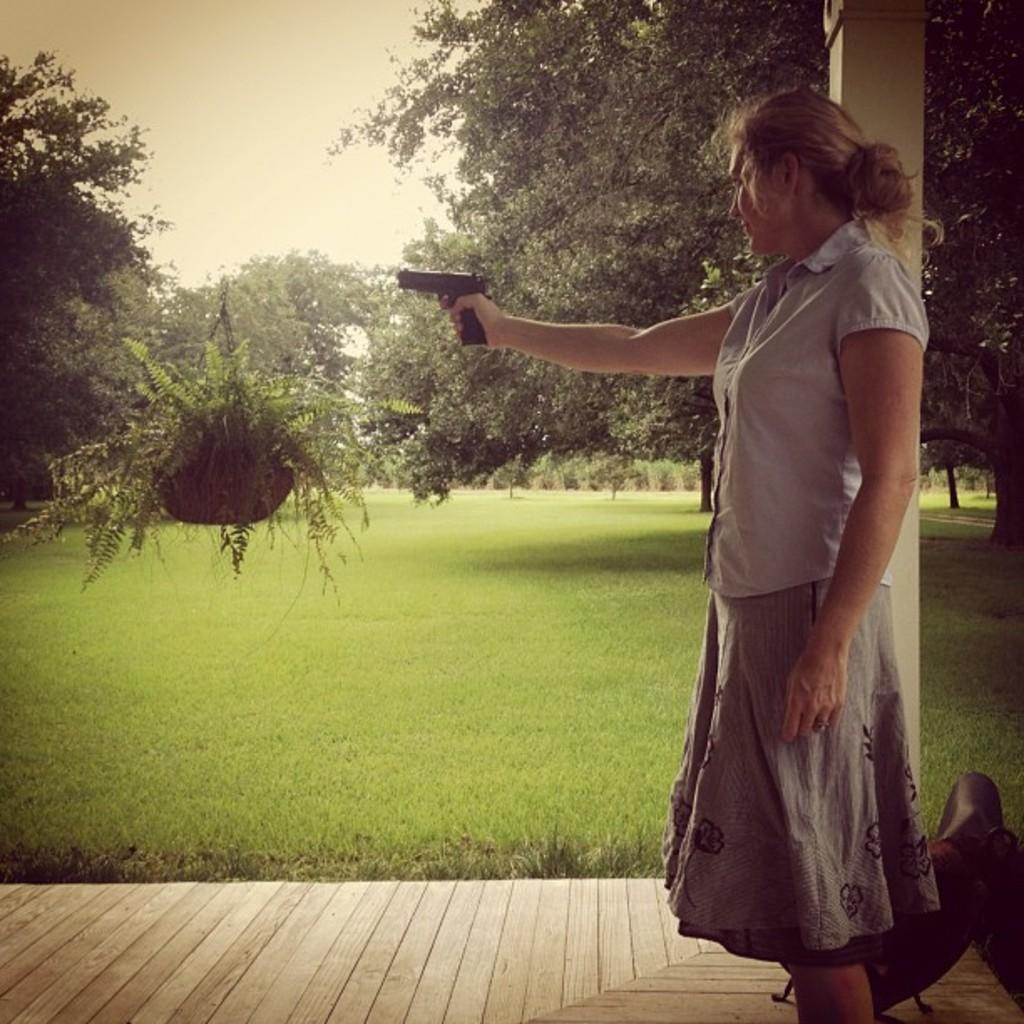Who is the main subject in the image? There is a woman in the image. What is the woman standing on? The woman is standing on a wooden surface. What is the woman holding in the image? The woman is holding a gun. What type of environment is depicted in the image? There is a garden in the image, which includes many trees. What shape is the spoon in the image? There is no spoon present in the image. What word is written on the trees in the image? There are no words written on the trees in the image; they are depicted as natural elements in the garden setting. 